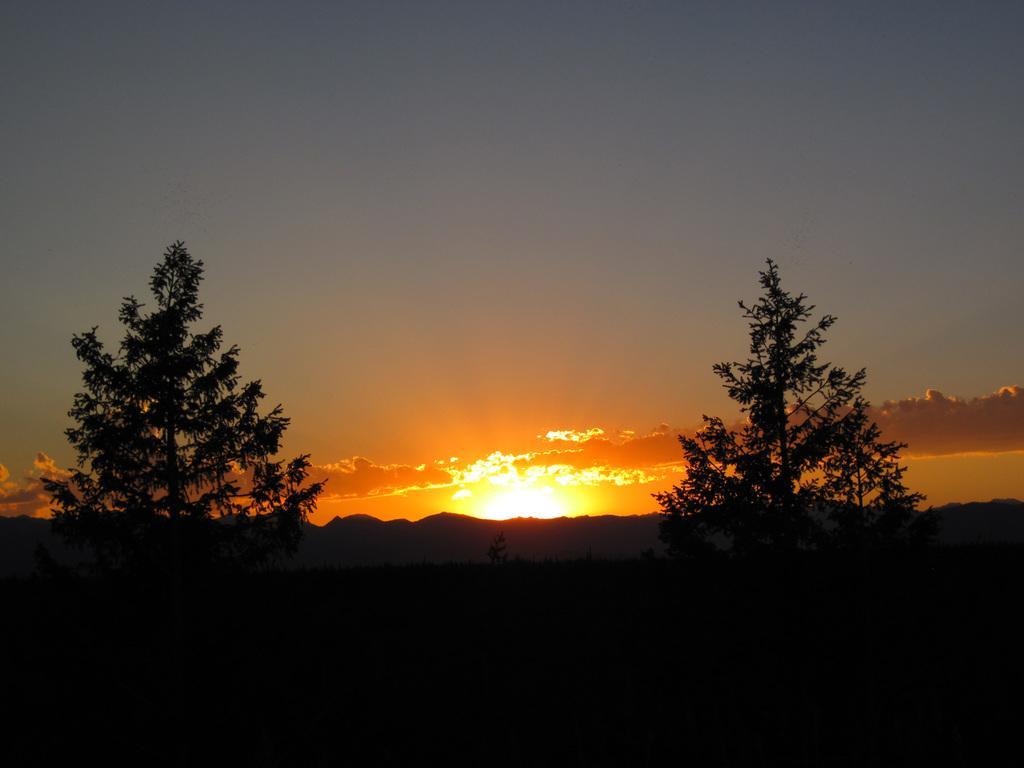What type of vegetation can be seen in the image? There are trees in the image. What is the condition of the sky in the image? The sky is cloudy in the image. Can the sun be seen in the image? Yes, the sun is visible in the image. What is the lighting like at the bottom of the image? The bottom part of the image is dark. What type of drug is being discussed in the image? There is no drug present or discussed in the image. What decision is being made in the image? There is no decision-making process depicted in the image. 